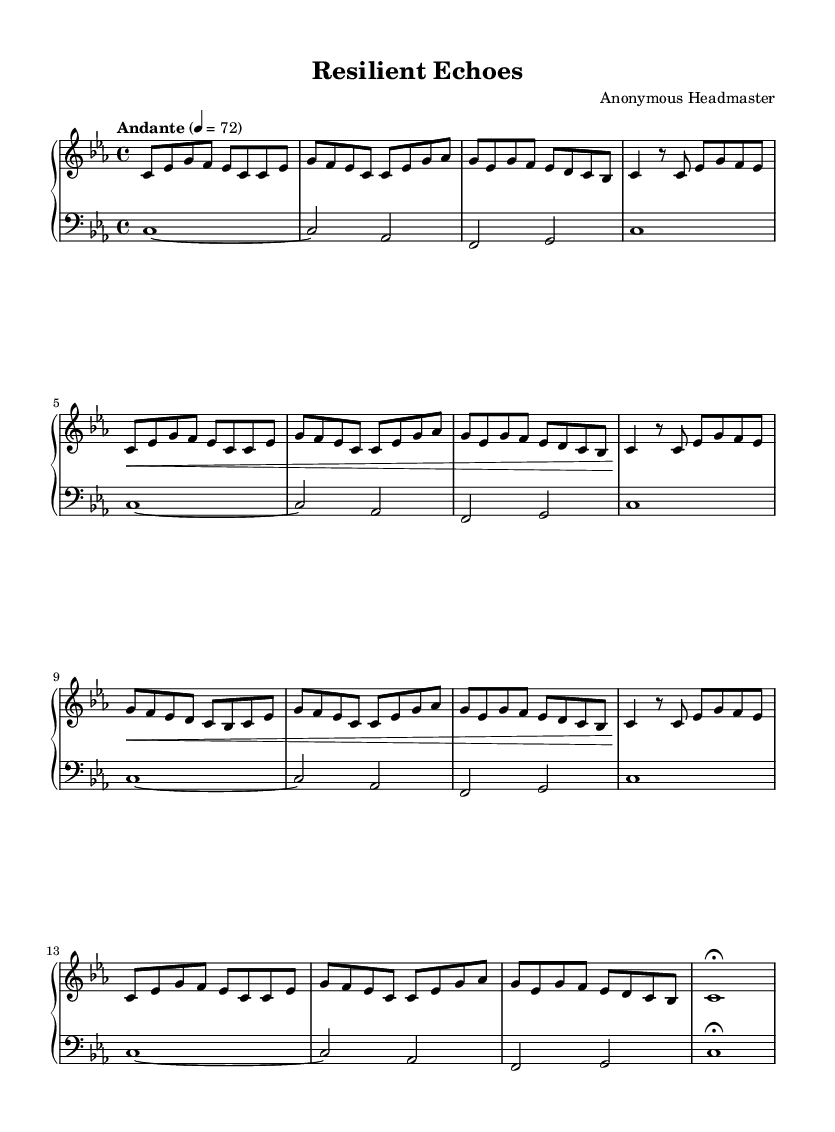What is the key signature of this music? The key signature is indicated in the global section, which specifies it as C minor. C minor has three flats: B flat, E flat, and A flat.
Answer: C minor What is the time signature of this piece? The time signature is shown in the global section of the music, indicating four beats per measure. It is written as 4/4.
Answer: 4/4 What is the tempo marking for this piece? The tempo marking in the global section states "Andante" with a metronome marking of 72 beats per minute. This suggests a moderate pace.
Answer: Andante 72 How many sections are there in this piece? The structure can be analyzed by looking at the labeled sections within the music, which denote different parts. There are Sections A, A', B, A'', and a Coda, totaling five distinct sections.
Answer: 5 Which dynamic marking appears in Section A? In Section A, the music indicates a crescendo marked by the symbol "<" before the notes, indicating the performer should gradually increase the volume from soft to loud.
Answer: Crescendo What thematic concept is explored throughout this minimalist piece? The repetition and gradual development of motifs in the music highlight themes of resilience and perseverance, offering a reflection on overcoming challenges.
Answer: Resilience and perseverance 